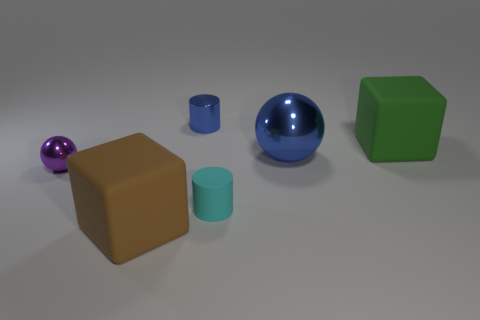There is a tiny purple thing that is made of the same material as the tiny blue cylinder; what shape is it?
Provide a succinct answer. Sphere. Is the size of the blue metal cylinder the same as the brown rubber object?
Offer a very short reply. No. What size is the cylinder in front of the small metallic thing in front of the green cube?
Provide a succinct answer. Small. What is the shape of the tiny object that is the same color as the big sphere?
Make the answer very short. Cylinder. How many cubes are tiny purple metallic things or tiny blue things?
Your response must be concise. 0. Do the cyan rubber object and the matte object that is behind the tiny purple object have the same size?
Offer a very short reply. No. Is the number of cyan matte things right of the tiny blue thing greater than the number of yellow cylinders?
Make the answer very short. Yes. What is the size of the cube that is the same material as the green object?
Make the answer very short. Large. Are there any things of the same color as the large ball?
Provide a succinct answer. Yes. How many objects are either large gray rubber cylinders or metallic things that are in front of the small blue thing?
Provide a short and direct response. 2. 